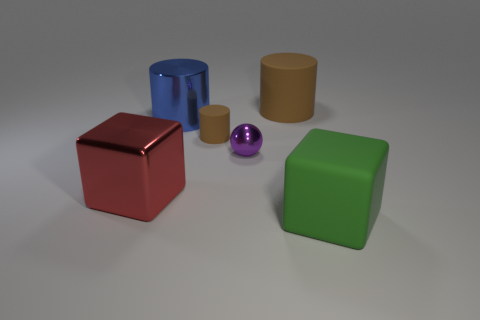Does the small ball have the same material as the large cube that is on the left side of the big blue cylinder? Based on the image, the small ball and the large cube seem to have different finishes—the ball has a glossy appearance while the cube has a matte finish. However, without being able to touch and feel the objects, it's difficult to determine if they are made from the same material solely based on visual inspection. 